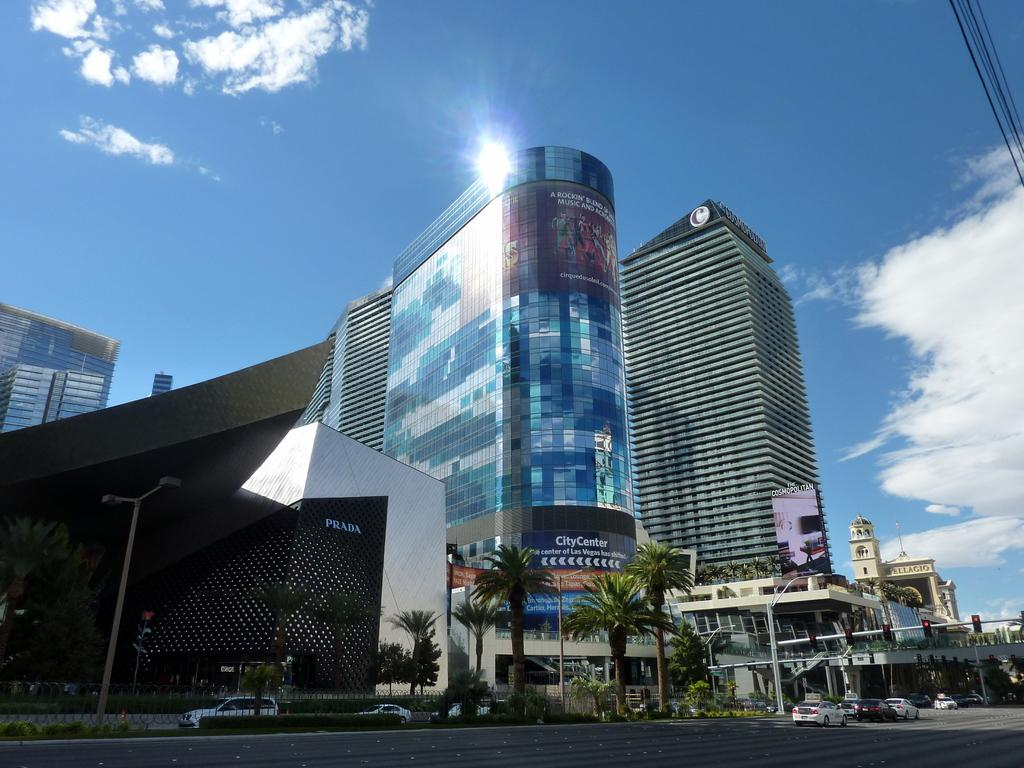<image>
Present a compact description of the photo's key features. An outdoor picture of tall buildings along a street indicates the Bellagio is nearby 